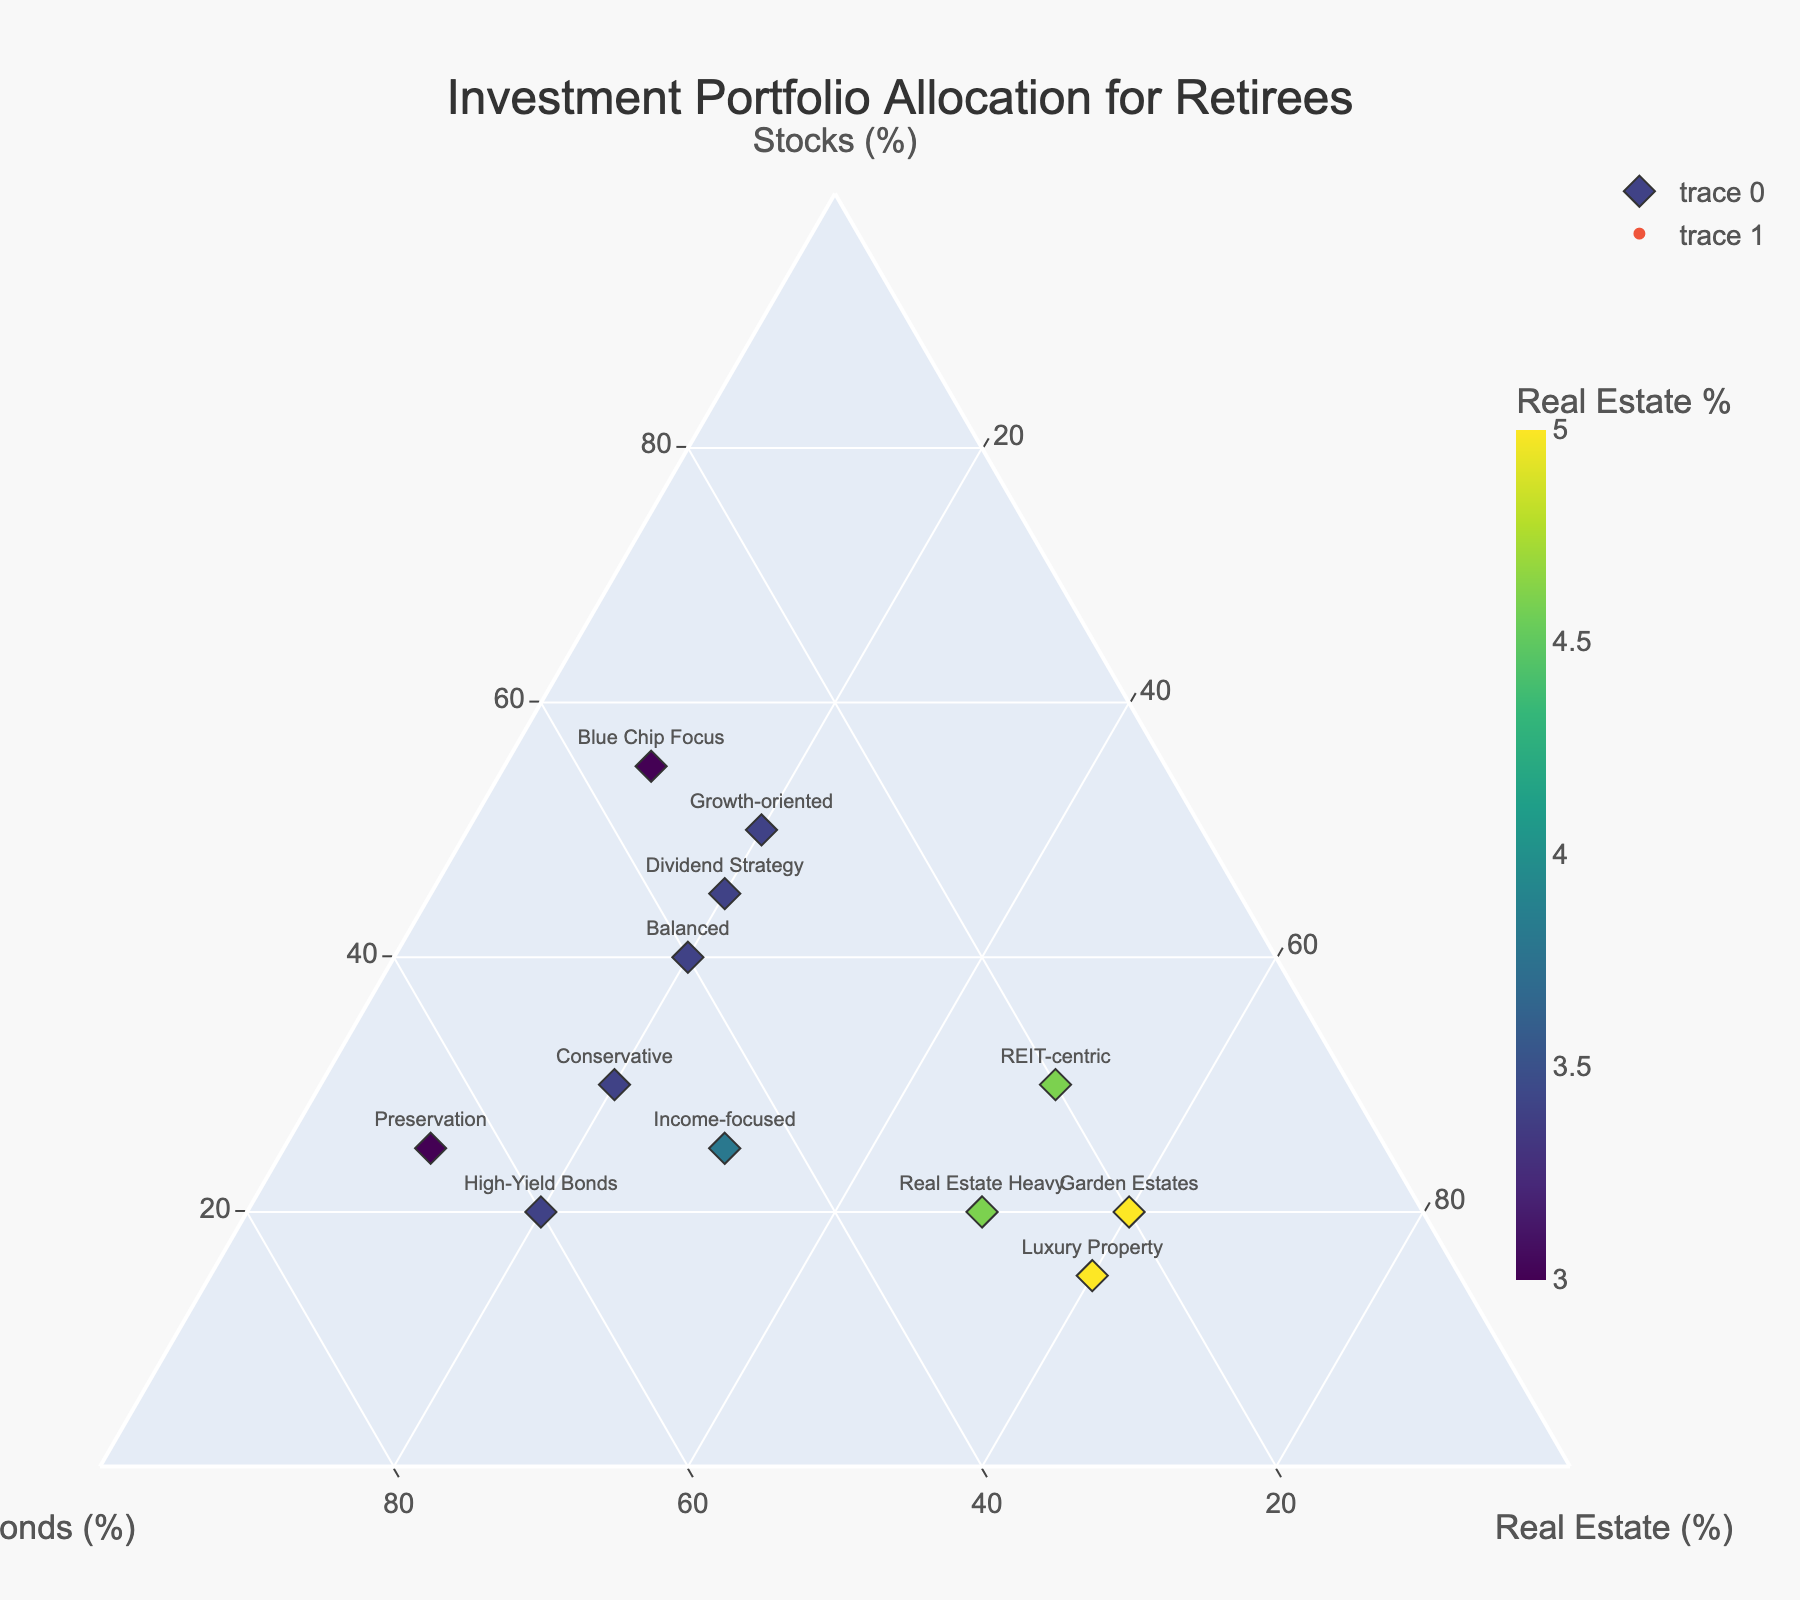What is the title of the figure? The title of the figure is always usually at the top or center, marked in larger and bolder text. Here, it states "Investment Portfolio Allocation for Retirees".
Answer: Investment Portfolio Allocation for Retirees What do the axes in the Ternary Plot represent? The plot has three axes labeled on the corners of the triangle. Each axis represents the percentage of one asset class: 'Stocks (%)', 'Bonds (%)', and 'Real Estate (%)'.
Answer: Stocks (%), Bonds (%), Real Estate (%) How many portfolio types are visualized in the plot? Counting the unique data points labeled on the plot yields the number of portfolio types. There are 12 different portfolio types identified on the plot.
Answer: 12 Which portfolio has the highest allocation in Real Estate? Examine the data points on the triangle grid. The portfolio furthest towards the Real Estate vertex has the highest allocation in real estate. "Luxury Property" and "Garden Estates" have the highest allocation of 60%.
Answer: Luxury Property, Garden Estates Which portfolios have equal allocations in Real Estate? Look for portfolios plotted on the same horizontal level within the Real Estate axis. "Luxury Property" and "Garden Estates" both allocate 60% to Real Estate.
Answer: Luxury Property, Garden Estates What's the difference in bond allocation between 'High-Yield Bonds' and 'Growth-oriented'? Subtract the bond percentage of 'Growth-oriented' from 'High-Yield Bonds'. 'High-Yield Bonds' has 60% and 'Growth-oriented' has 30%, so the difference is 60% - 30% = 30%.
Answer: 30% What portfolio has the lowest allocation in real estate? Locate the portfolio closest to the Stocks-Bonds edge, meaning lowest on the Real Estate axis. "Blue Chip Focus" and "Preservation" have the lowest allocation of 10%.
Answer: Blue Chip Focus, Preservation Which portfolio favors stocks the most? Identify the portfolio positioned nearest to the Stocks axis. "Blue Chip Focus" with 55% stocks allocation is the highest.
Answer: Blue Chip Focus How does the 'Real Estate Heavy' portfolio allocate its assets? Point at 'Real Estate Heavy', and read the allocations: "20% Stocks, 30% Bonds, 50% Real Estate".
Answer: 20% Stocks, 30% Bonds, 50% Real Estate Are there any portfolios with equal stocks and bonds allocations? Check for portfolios plotted along lines that indicate equal stocks and bonds. "Balanced" is the only portfolio with 40% stocks and 40% bonds.
Answer: Balanced 